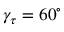Convert formula to latex. <formula><loc_0><loc_0><loc_500><loc_500>\gamma _ { \tau } = 6 0 ^ { \circ }</formula> 